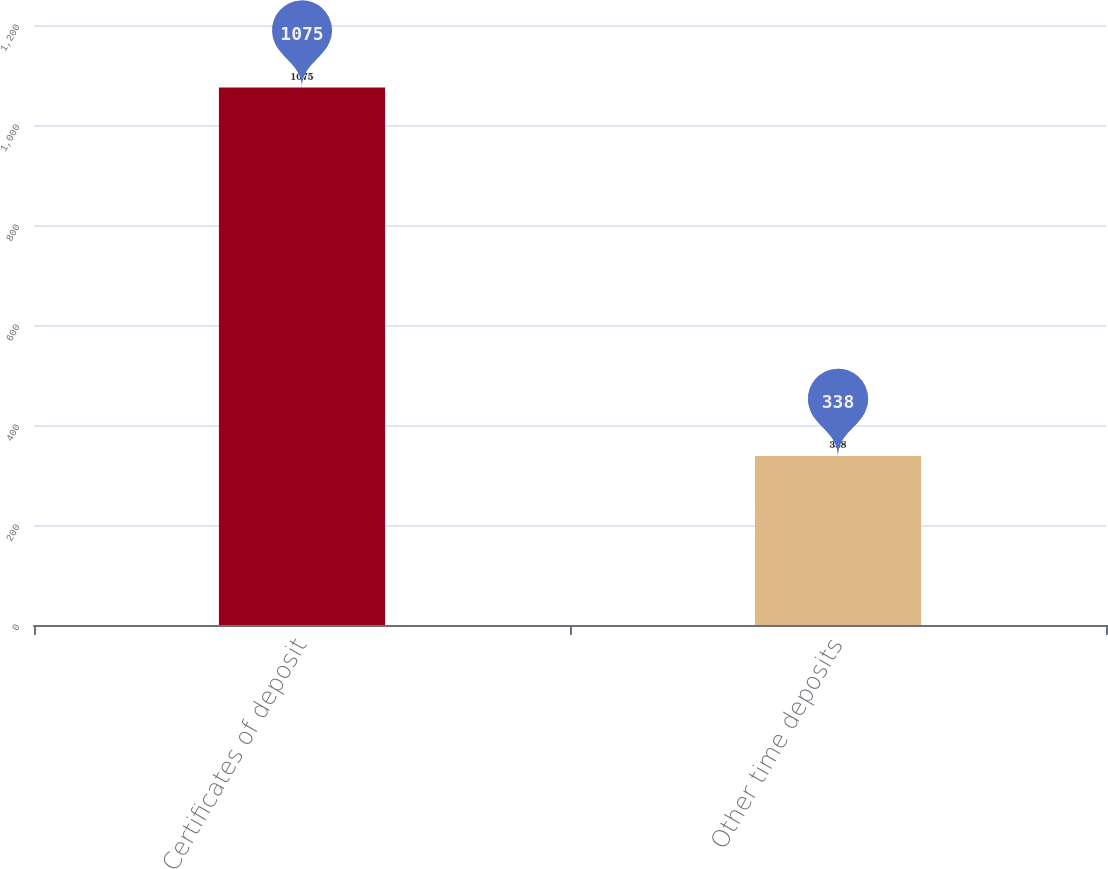Convert chart to OTSL. <chart><loc_0><loc_0><loc_500><loc_500><bar_chart><fcel>Certificates of deposit<fcel>Other time deposits<nl><fcel>1075<fcel>338<nl></chart> 